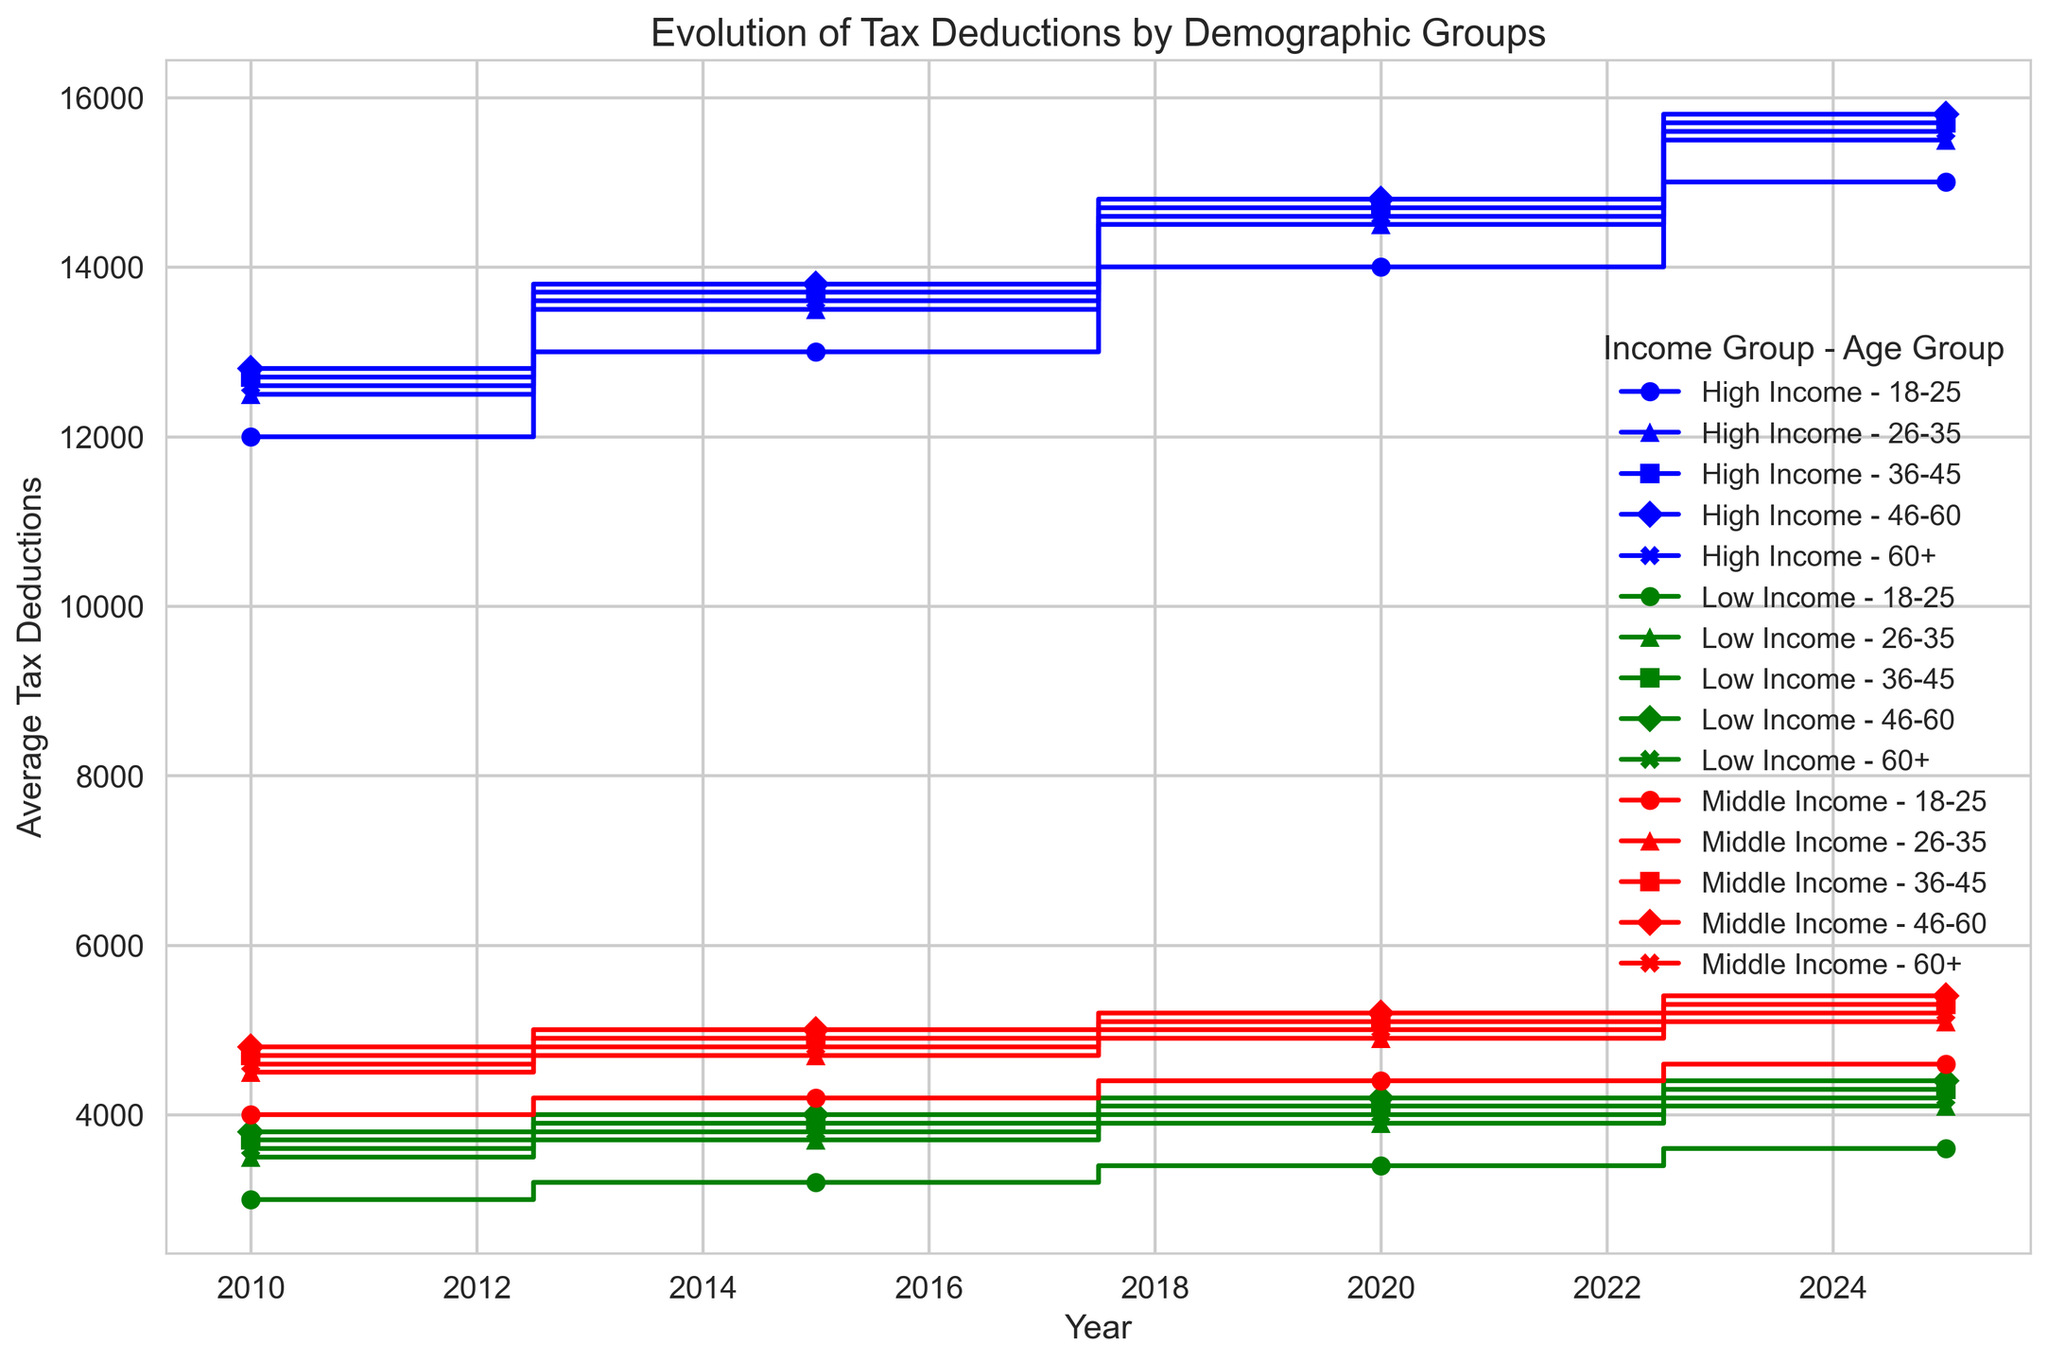Which income group showed the highest average tax deductions consistently from 2010 to 2025? To find the highest average tax deductions, look at the steps of each income group across different years. The high-income group consistently shows the highest averages.
Answer: High Income Which age group within the Low-Income group witnessed the largest increase in average tax deductions from 2010 to 2025? Track the steps of each age group within the Low-Income group across the years. The largest increase is observed in the 46-60 age group (3800 in 2010 to 4400 in 2025, an increase of 600).
Answer: 46-60 Among the Middle-Income group, which year had the lowest average tax deductions for the 18-25 age group? Follow the step plot for Middle-Income 18-25 age group and identify the lowest point. The lowest average tax deduction is in 2010 (4000).
Answer: 2010 What is the difference in average tax deductions between High Income and Low Income for the 60+ age group in 2025? Find and subtract the average deductions for 60+ age group in 2025 for High Income (15600) and Low Income (4200). The difference is 15600 - 4200 = 11400.
Answer: 11400 For the Middle-Income 36-45 age group, what is the rate of increase in tax deductions from 2020 to 2025? Look at the average tax deductions for this group in 2020 (5100) and 2025 (5300). The rate of increase is (5300-5100)/5100 * 100 ≈ 3.92%.
Answer: 3.92% Was there any age group in the Low-Income group that experienced a decrease in deductions between any two consecutive years? Compare the average tax deductions year-over-year for each age group within the Low-Income bracket. The 60+ age group saw a decrease from 3800 in 2015 to 4000 in 2020.
Answer: No Which demographic group (income and age) had the most significant average tax deductions in 2015? Look at the highest peak on the step plot for 2015 across all demographic groups. The High Income 46-60 age group had an average deduction of 13800 in 2015.
Answer: High Income 46-60 What is the average of the average tax deductions for all age groups within the Low-Income group in 2025? Calculate the mean of deductions for all age groups within the Low-Income group in 2025 (3600, 4100, 4300, 4400, 4200). Average = (3600+4100+4300+4400+4200)/5 = 4120
Answer: 4120 Compare the change in tax deductions from 2010 to 2015 for the Middle-Income 46-60 age group. Find the deductions for 2010 (4800) and 2015 (5000). The change is 5000 - 4800 = 200, an increase of 200.
Answer: 200 